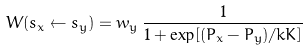Convert formula to latex. <formula><loc_0><loc_0><loc_500><loc_500>W ( s _ { x } \leftarrow s _ { y } ) = w _ { y } \, \frac { 1 } { 1 + \exp [ ( P _ { x } - P _ { y } ) / k K ] } \,</formula> 